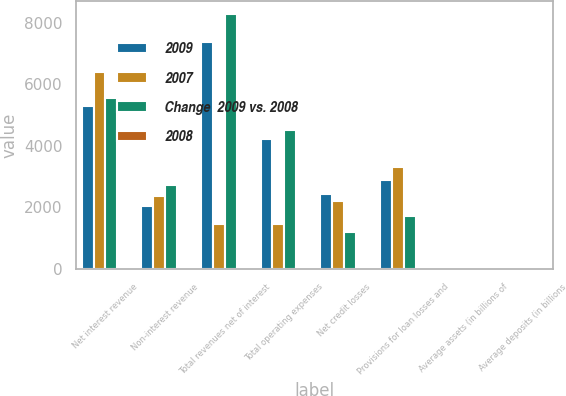<chart> <loc_0><loc_0><loc_500><loc_500><stacked_bar_chart><ecel><fcel>Net interest revenue<fcel>Non-interest revenue<fcel>Total revenues net of interest<fcel>Total operating expenses<fcel>Net credit losses<fcel>Provisions for loan losses and<fcel>Average assets (in billions of<fcel>Average deposits (in billions<nl><fcel>2009<fcel>5303<fcel>2051<fcel>7354<fcel>4232<fcel>2435<fcel>2893<fcel>61<fcel>36<nl><fcel>2007<fcel>6391<fcel>2367<fcel>1450<fcel>1450<fcel>2205<fcel>3322<fcel>76<fcel>40<nl><fcel>Change  2009 vs. 2008<fcel>5567<fcel>2712<fcel>8279<fcel>4503<fcel>1189<fcel>1711<fcel>63<fcel>38<nl><fcel>2008<fcel>17<fcel>13<fcel>16<fcel>52<fcel>10<fcel>13<fcel>20<fcel>10<nl></chart> 